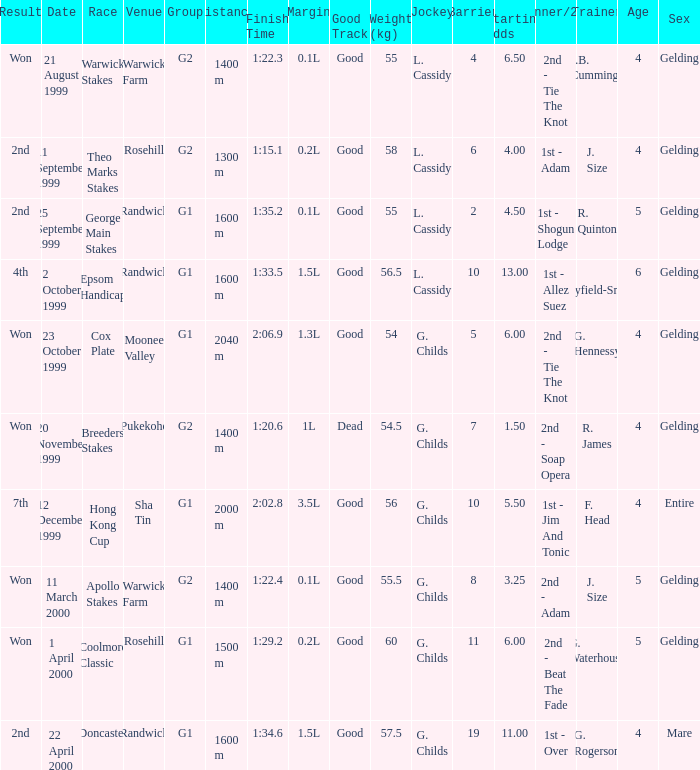List the weight for 56 kilograms. 2000 m. 